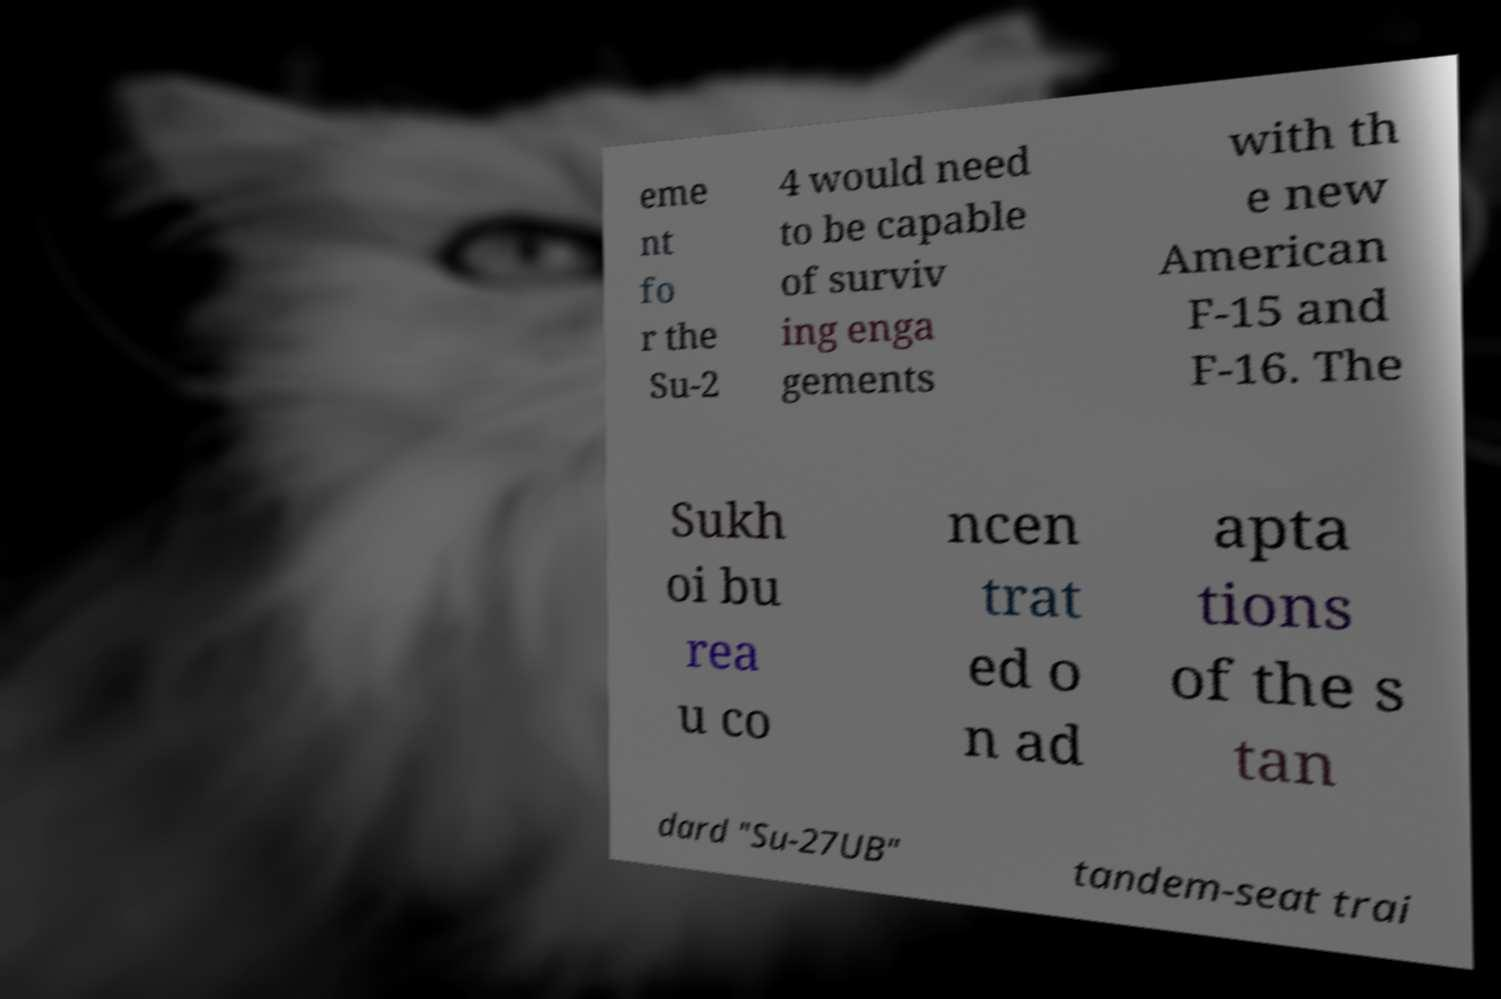Could you extract and type out the text from this image? eme nt fo r the Su-2 4 would need to be capable of surviv ing enga gements with th e new American F-15 and F-16. The Sukh oi bu rea u co ncen trat ed o n ad apta tions of the s tan dard "Su-27UB" tandem-seat trai 